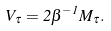Convert formula to latex. <formula><loc_0><loc_0><loc_500><loc_500>V _ { \tau } = 2 \beta ^ { - 1 } M _ { \tau } .</formula> 